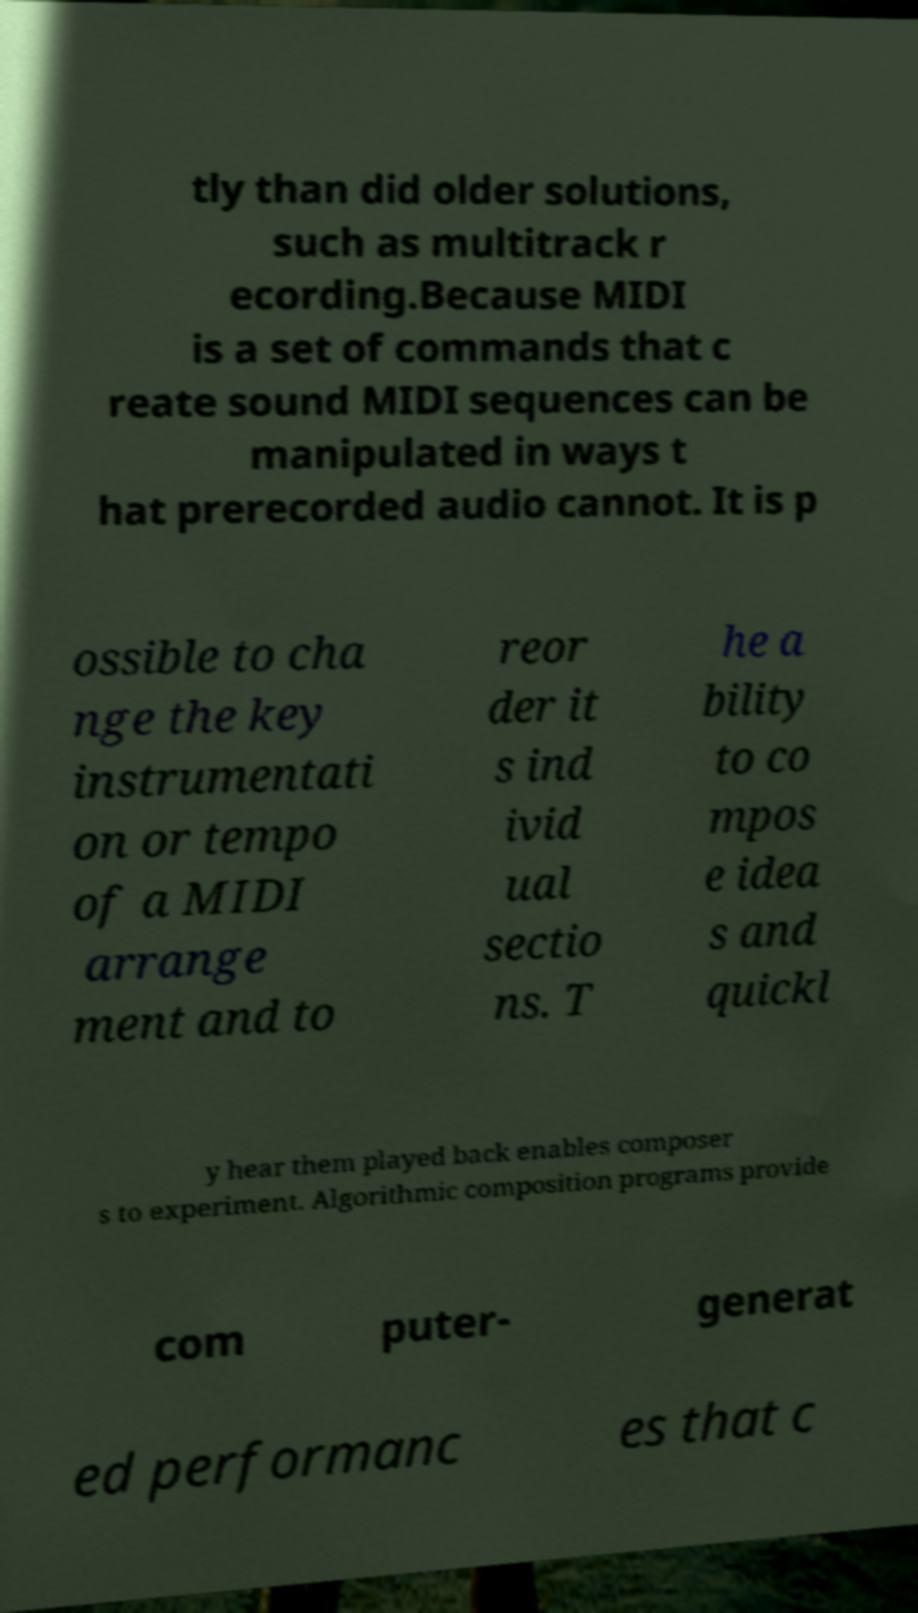Can you read and provide the text displayed in the image?This photo seems to have some interesting text. Can you extract and type it out for me? tly than did older solutions, such as multitrack r ecording.Because MIDI is a set of commands that c reate sound MIDI sequences can be manipulated in ways t hat prerecorded audio cannot. It is p ossible to cha nge the key instrumentati on or tempo of a MIDI arrange ment and to reor der it s ind ivid ual sectio ns. T he a bility to co mpos e idea s and quickl y hear them played back enables composer s to experiment. Algorithmic composition programs provide com puter- generat ed performanc es that c 